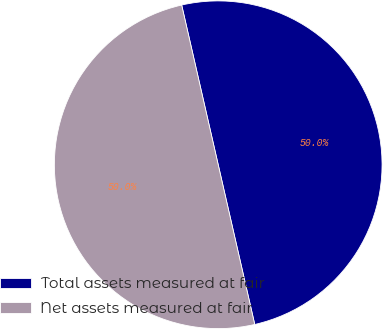Convert chart to OTSL. <chart><loc_0><loc_0><loc_500><loc_500><pie_chart><fcel>Total assets measured at fair<fcel>Net assets measured at fair<nl><fcel>50.0%<fcel>50.0%<nl></chart> 